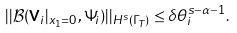Convert formula to latex. <formula><loc_0><loc_0><loc_500><loc_500>| | \mathcal { B } ( { \mathbf V } _ { i } | _ { x _ { 1 } = 0 } , \Psi _ { i } ) | | _ { H ^ { s } ( \Gamma _ { T } ) } \leq \delta \theta ^ { s - \alpha - 1 } _ { i } .</formula> 